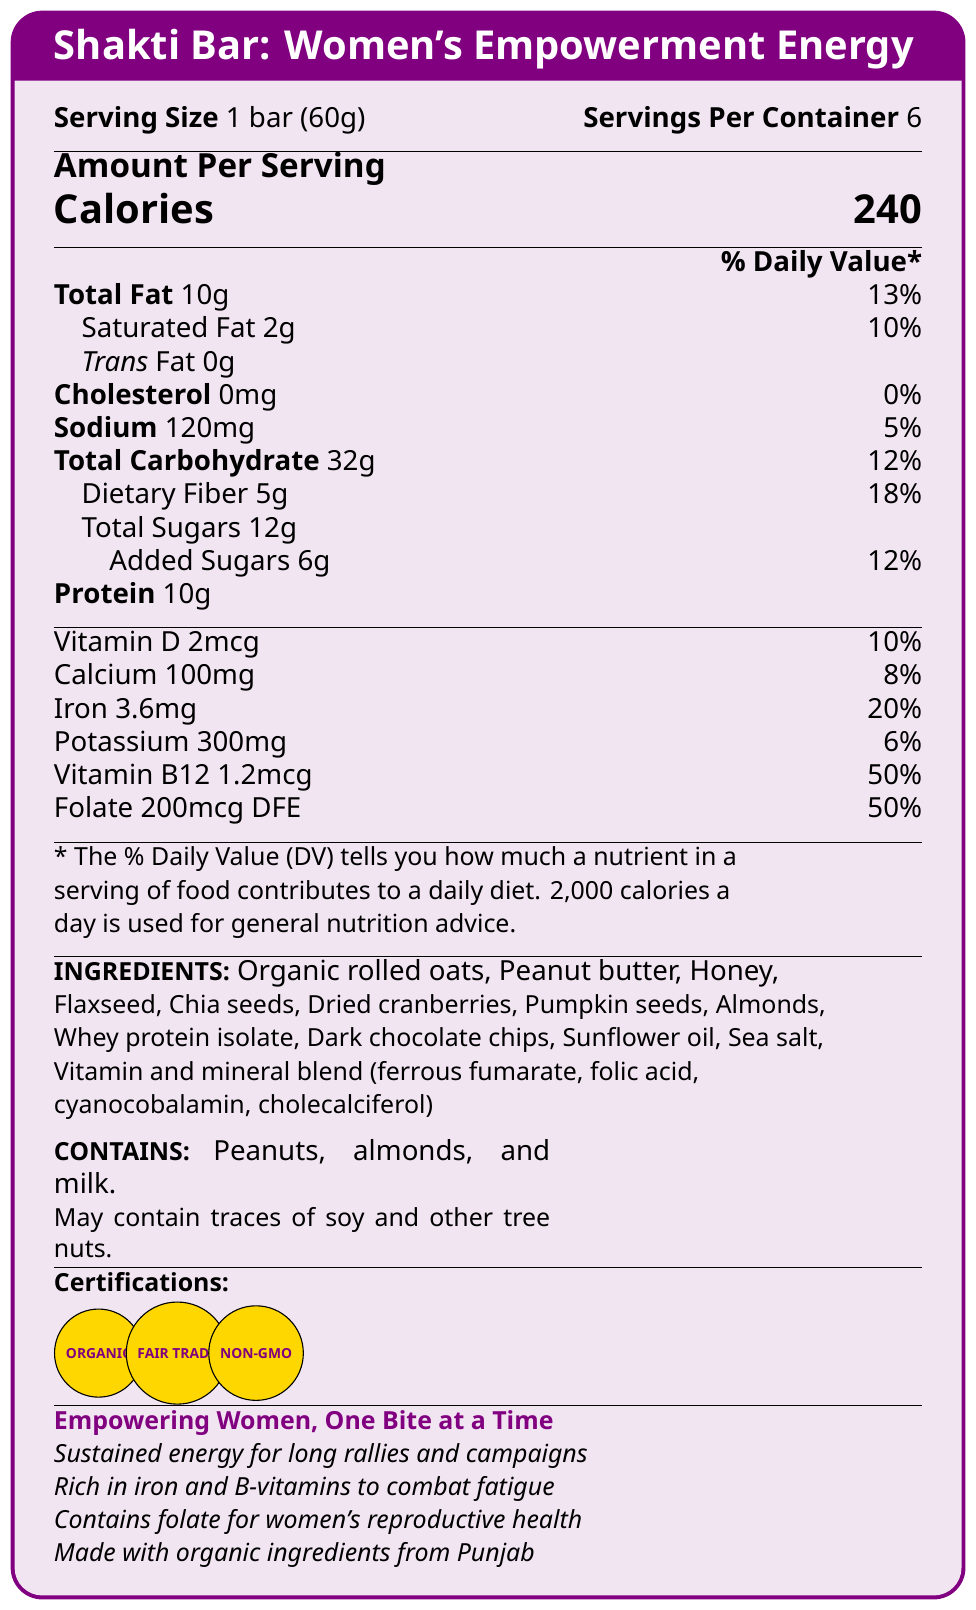what is the serving size of the Shakti Bar? The serving size is mentioned under the title "Serving Size" in the document.
Answer: 1 bar (60g) how many calories does one Shakti Bar contain? The calorie content is prominently displayed in a larger font under "Amount Per Serving."
Answer: 240 calories what is the total amount of protein in one serving of Shakti Bar? The protein content is listed under "Amount Per Serving" in the document.
Answer: 10g what percentage of daily iron does one Shakti Bar provide? The daily value percentage for iron is listed in the "Amount Per Serving" section.
Answer: 20% how much dietary fiber is in one bar of Shakti Bar? The dietary fiber content is provided under "Total Carbohydrate" in the "Amount Per Serving" section.
Answer: 5g which ingredient is not present in Shakti Bar? A. Honey B. Artificial flavoring C. Pumpkin seeds The ingredients list shows that artificial flavoring is not included.
Answer: B. Artificial flavoring what kind of oil is used in Shakti Bar? A. Canola oil B. Sunflower oil C. Coconut oil Sunflower oil is listed among the ingredients in the document.
Answer: B. Sunflower oil how many servings are there per container of Shakti Bar? The number of servings per container is specified under "Servings Per Container."
Answer: 6 servings does the Shakti Bar contain any allergens? The allergen information is mentioned explicitly, stating it contains peanuts, almonds, and milk.
Answer: Yes what are the certification seals shown in the document? The certification seals are mentioned at the bottom of the document.
Answer: Certified Organic, Fair Trade Certified, Non-GMO Project Verified is there any trans fat in Shakti Bar? The trans fat content is listed as 0g in the document.
Answer: No summarize the main idea of the Shakti Bar's nutrition facts label. The document is mainly about the nutritional content of a specially formulated energy bar for women activists, including its ingredients, allergen information, marketing claims, and certifications, emphasizing sustained energy and women's health benefits.
Answer: The Shakti Bar: Women's Empowerment Energy provides 240 calories per serving, with significant amounts of protein, fiber, iron, and B-vitamins, made from organic and locally sourced ingredients with a focus on sustained energy release for women activists. It is certified organic, fair-trade, and non-GMO. how many grams of added sugars does one bar contain? The added sugars are specifically listed under "Total Carbohydrate."
Answer: 6g how much vitamin B12 does one Shakti Bar contain? The amount of vitamin B12 is listed in the "Amount Per Serving" section.
Answer: 1.2mcg are the ingredients in Shakti Bar locally sourced? The marketing claims mention that the ingredients are organic and locally sourced from Punjab.
Answer: Yes does the document specify the price of the Shakti Bar? The document does not include any information regarding the price of the Shakti Bar.
Answer: Not enough information 